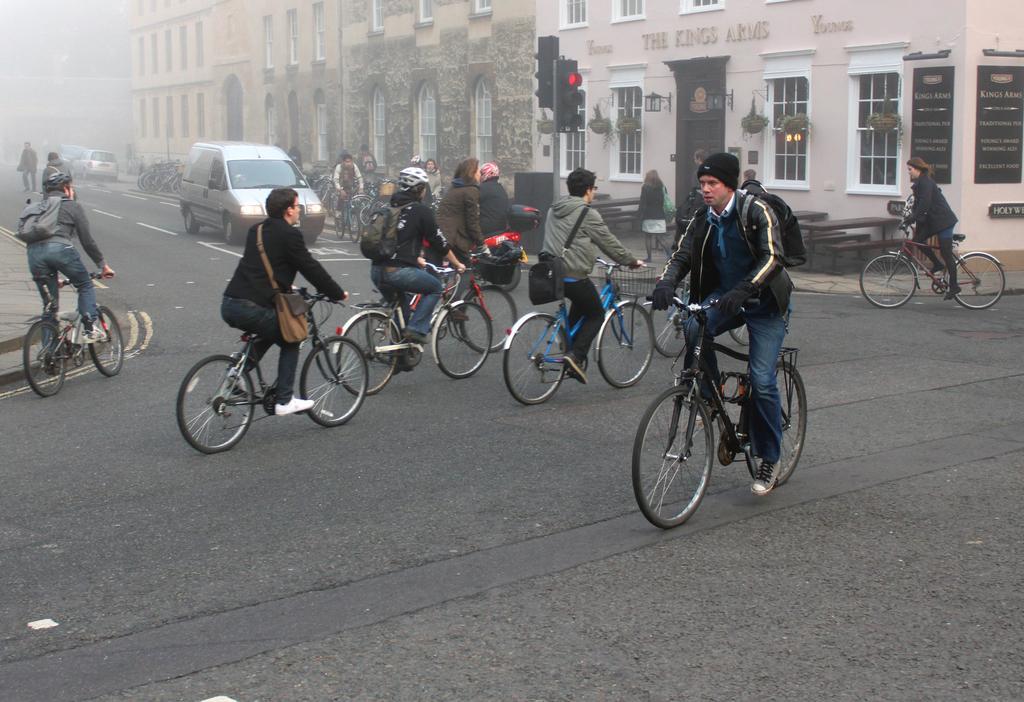Can you describe this image briefly? There are people riding bicycles on the road. We can see traffic signals on pole, vehicles, buildings, house plants, tables, benches and boards. In the background it is blur. 